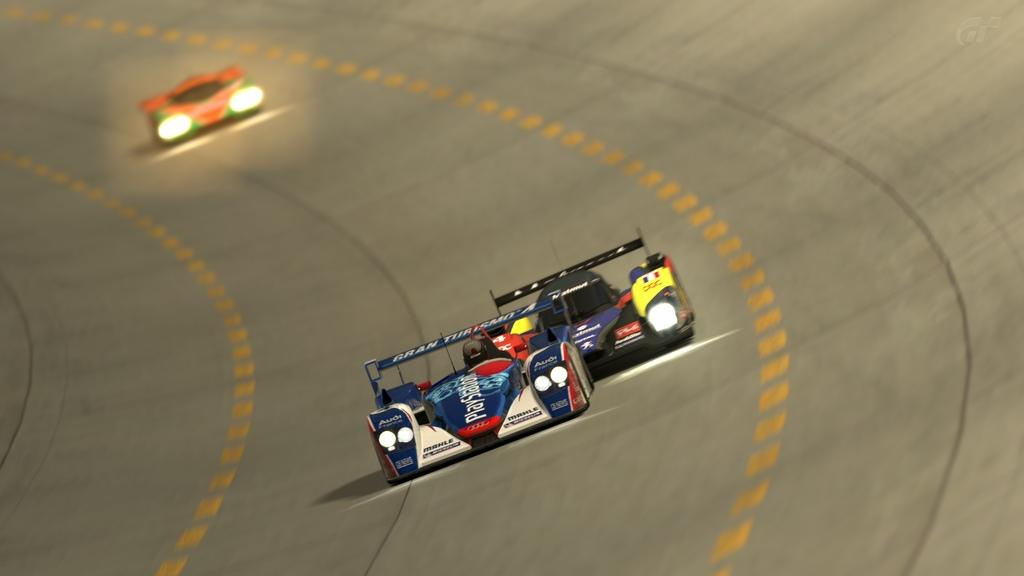What type of vehicles are in the image? There are racing cars in the image. Where are the racing cars located? The racing cars are on a track. What else can be seen in the image besides the racing cars? There are other cars visible in the background. How are the cars in the background depicted? The cars in the background appear blurry. What does the mother do to the base in the image? There is no mother or base present in the image. 